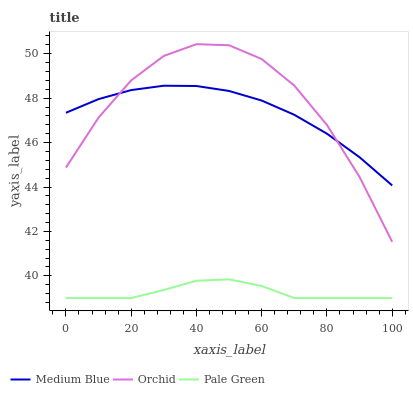Does Pale Green have the minimum area under the curve?
Answer yes or no. Yes. Does Orchid have the maximum area under the curve?
Answer yes or no. Yes. Does Medium Blue have the minimum area under the curve?
Answer yes or no. No. Does Medium Blue have the maximum area under the curve?
Answer yes or no. No. Is Medium Blue the smoothest?
Answer yes or no. Yes. Is Orchid the roughest?
Answer yes or no. Yes. Is Orchid the smoothest?
Answer yes or no. No. Is Medium Blue the roughest?
Answer yes or no. No. Does Orchid have the lowest value?
Answer yes or no. No. Does Orchid have the highest value?
Answer yes or no. Yes. Does Medium Blue have the highest value?
Answer yes or no. No. Is Pale Green less than Medium Blue?
Answer yes or no. Yes. Is Medium Blue greater than Pale Green?
Answer yes or no. Yes. Does Orchid intersect Medium Blue?
Answer yes or no. Yes. Is Orchid less than Medium Blue?
Answer yes or no. No. Is Orchid greater than Medium Blue?
Answer yes or no. No. Does Pale Green intersect Medium Blue?
Answer yes or no. No. 